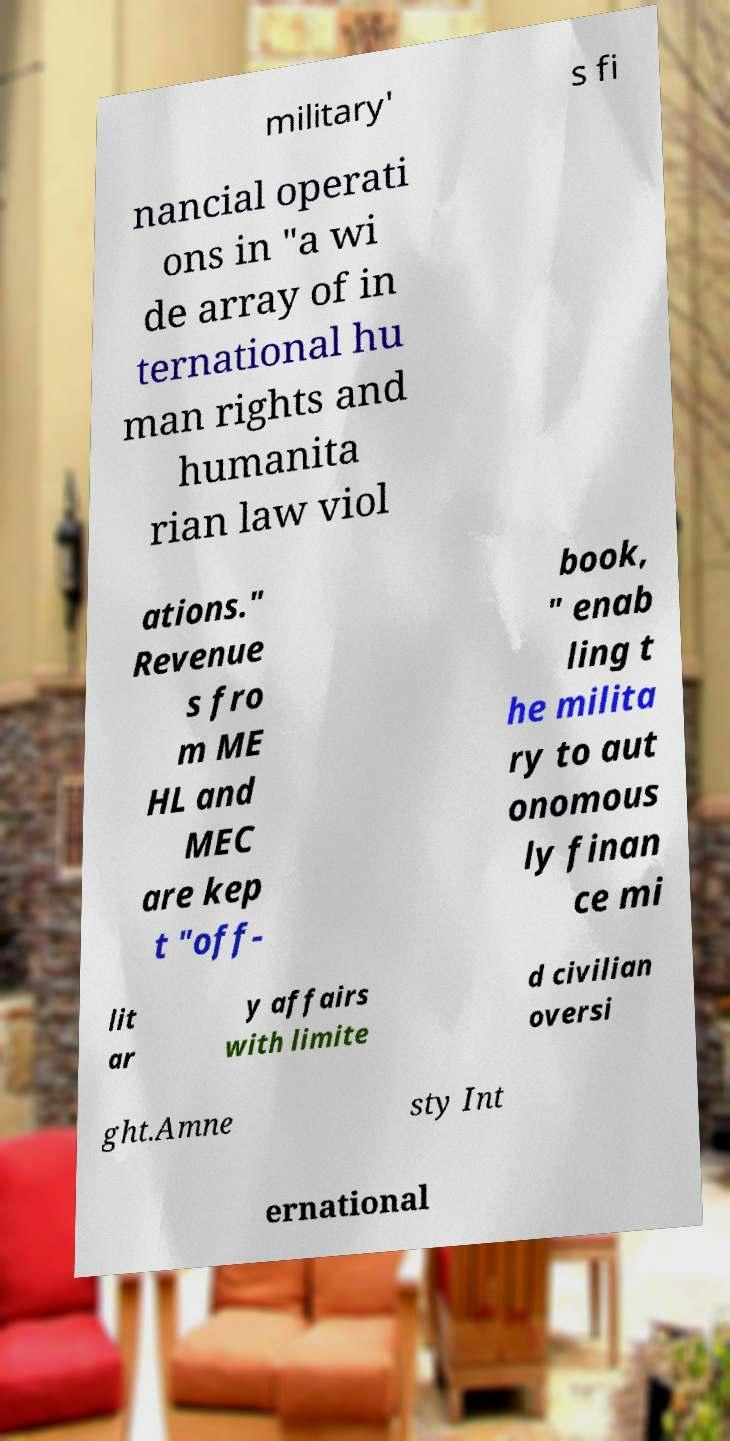Could you extract and type out the text from this image? military' s fi nancial operati ons in "a wi de array of in ternational hu man rights and humanita rian law viol ations." Revenue s fro m ME HL and MEC are kep t "off- book, " enab ling t he milita ry to aut onomous ly finan ce mi lit ar y affairs with limite d civilian oversi ght.Amne sty Int ernational 